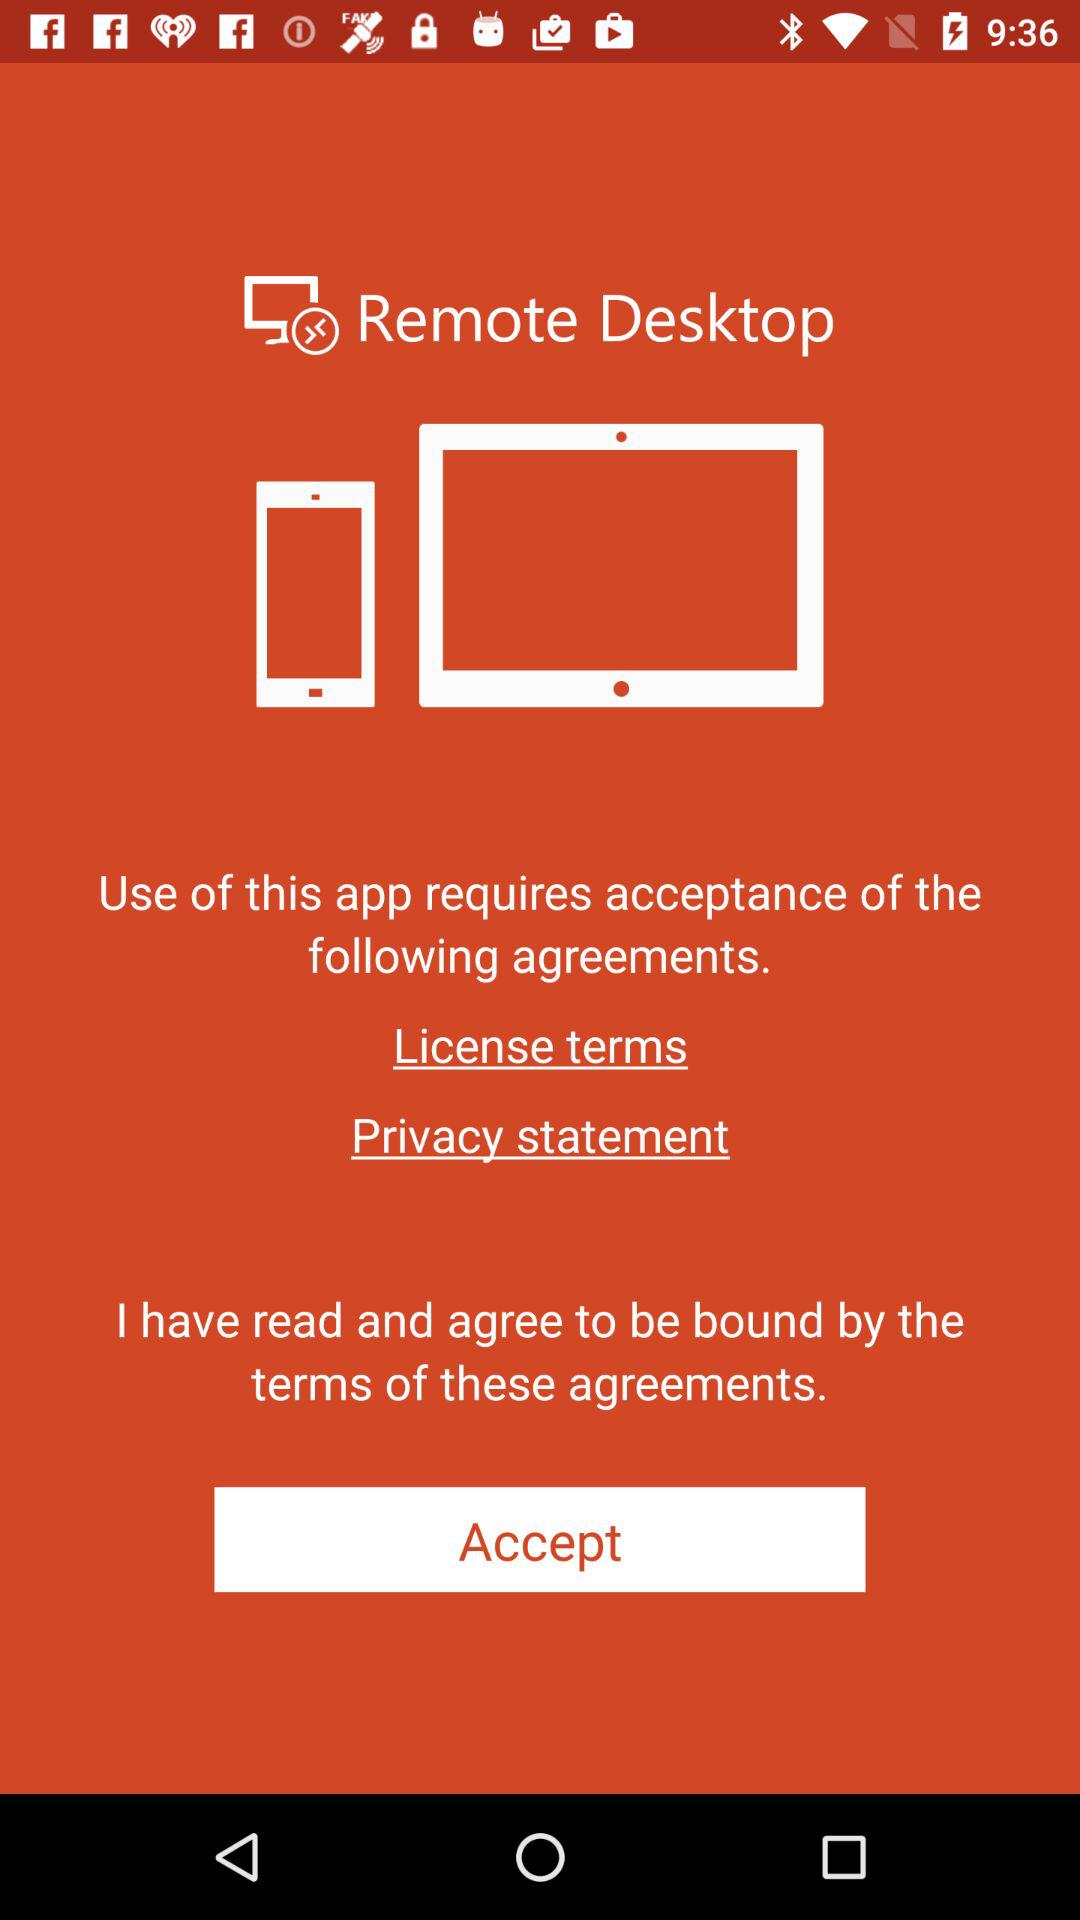What is the agreement for the application? The agreements are "License terms" and "Privacy statement". 